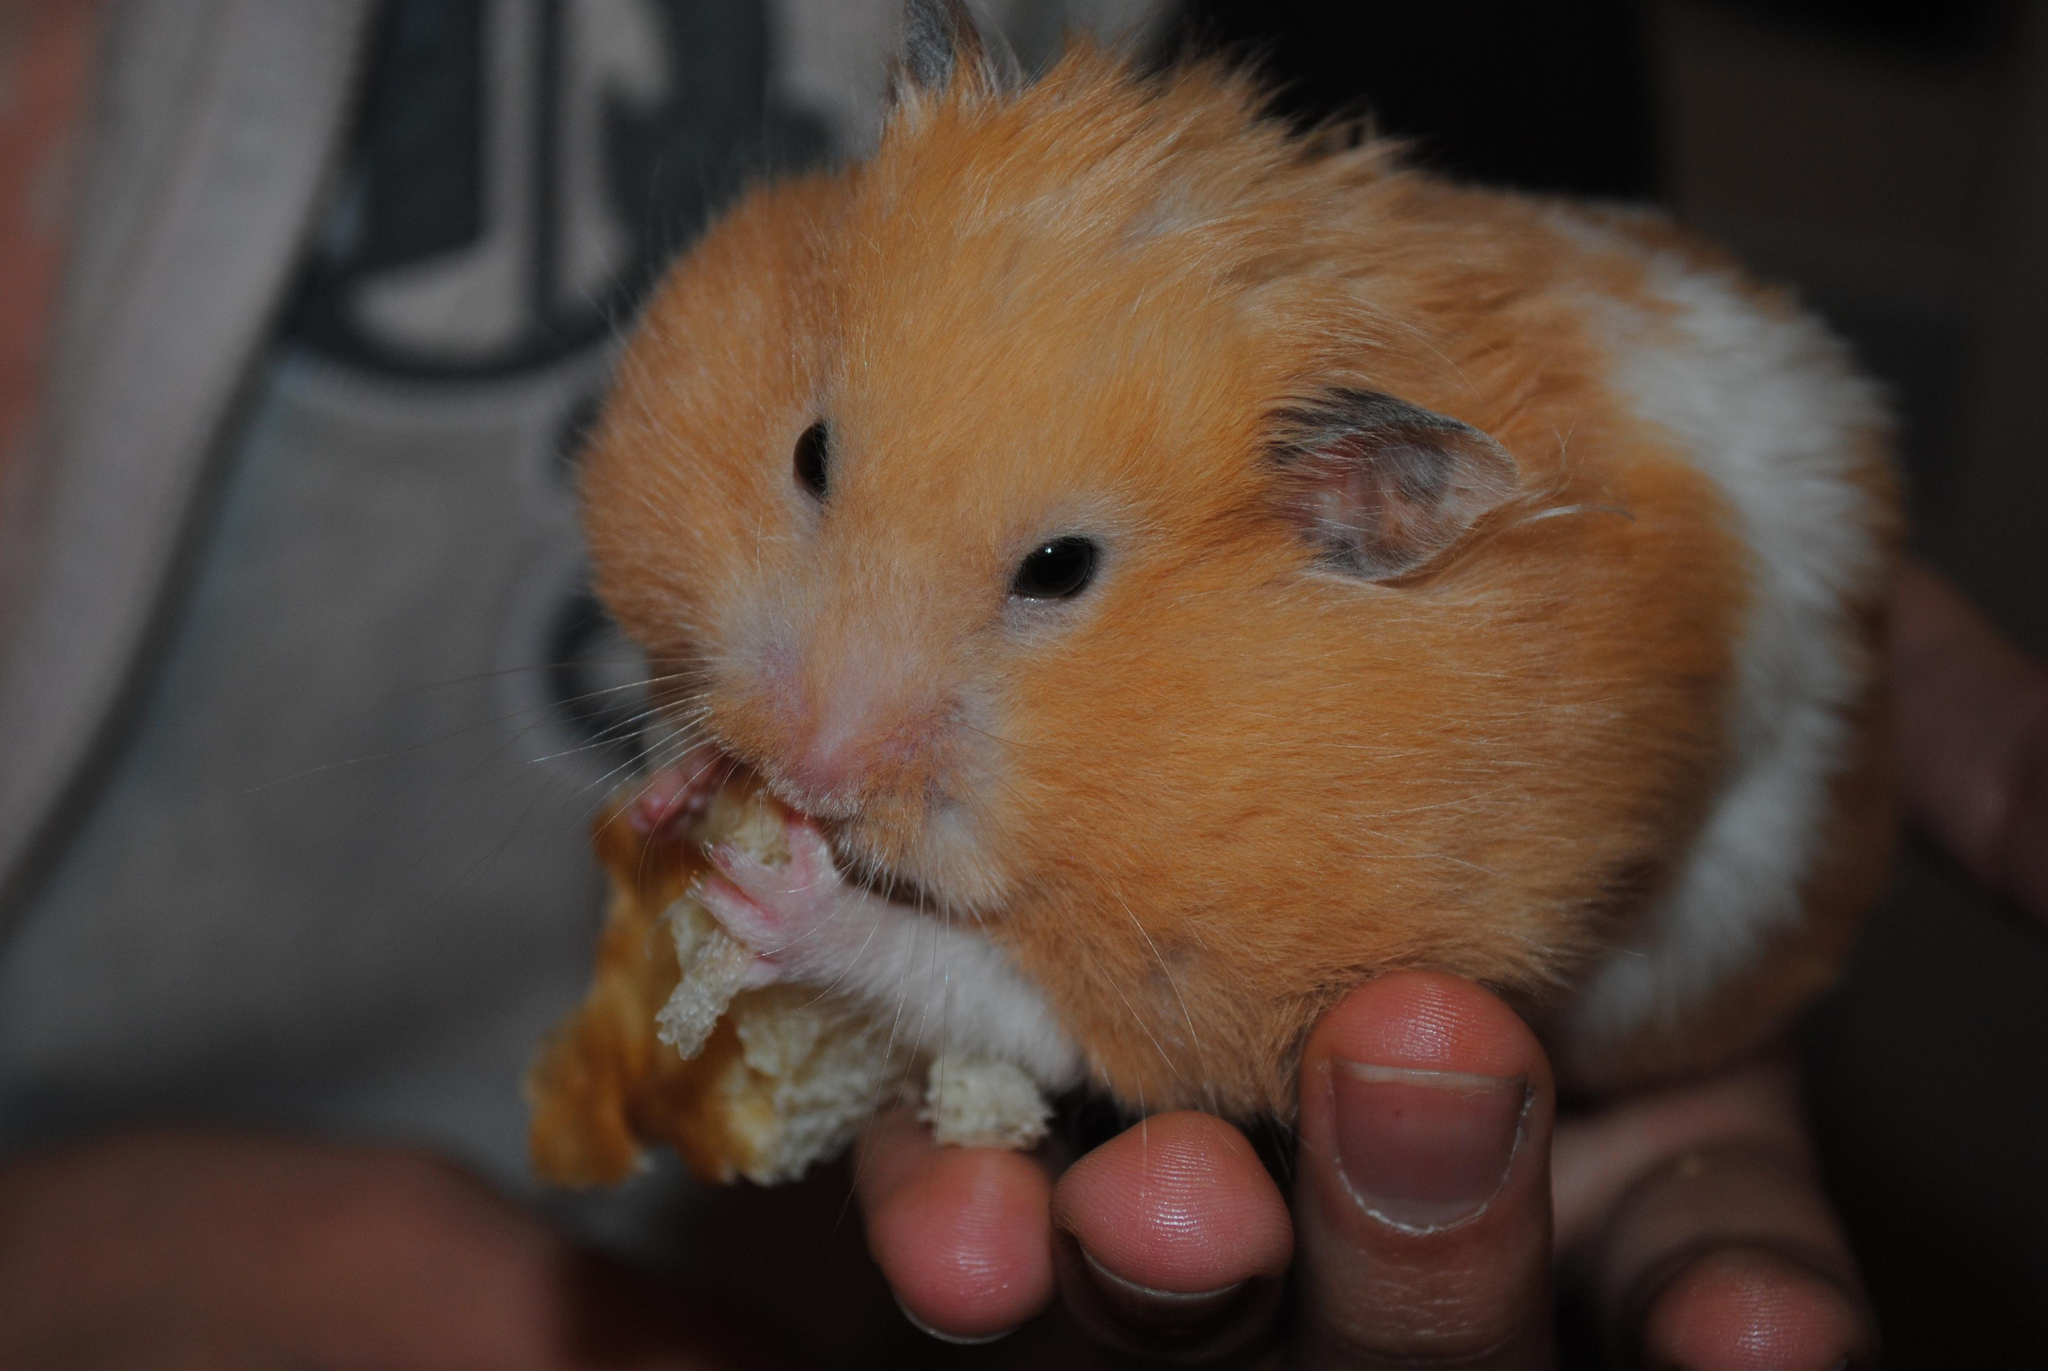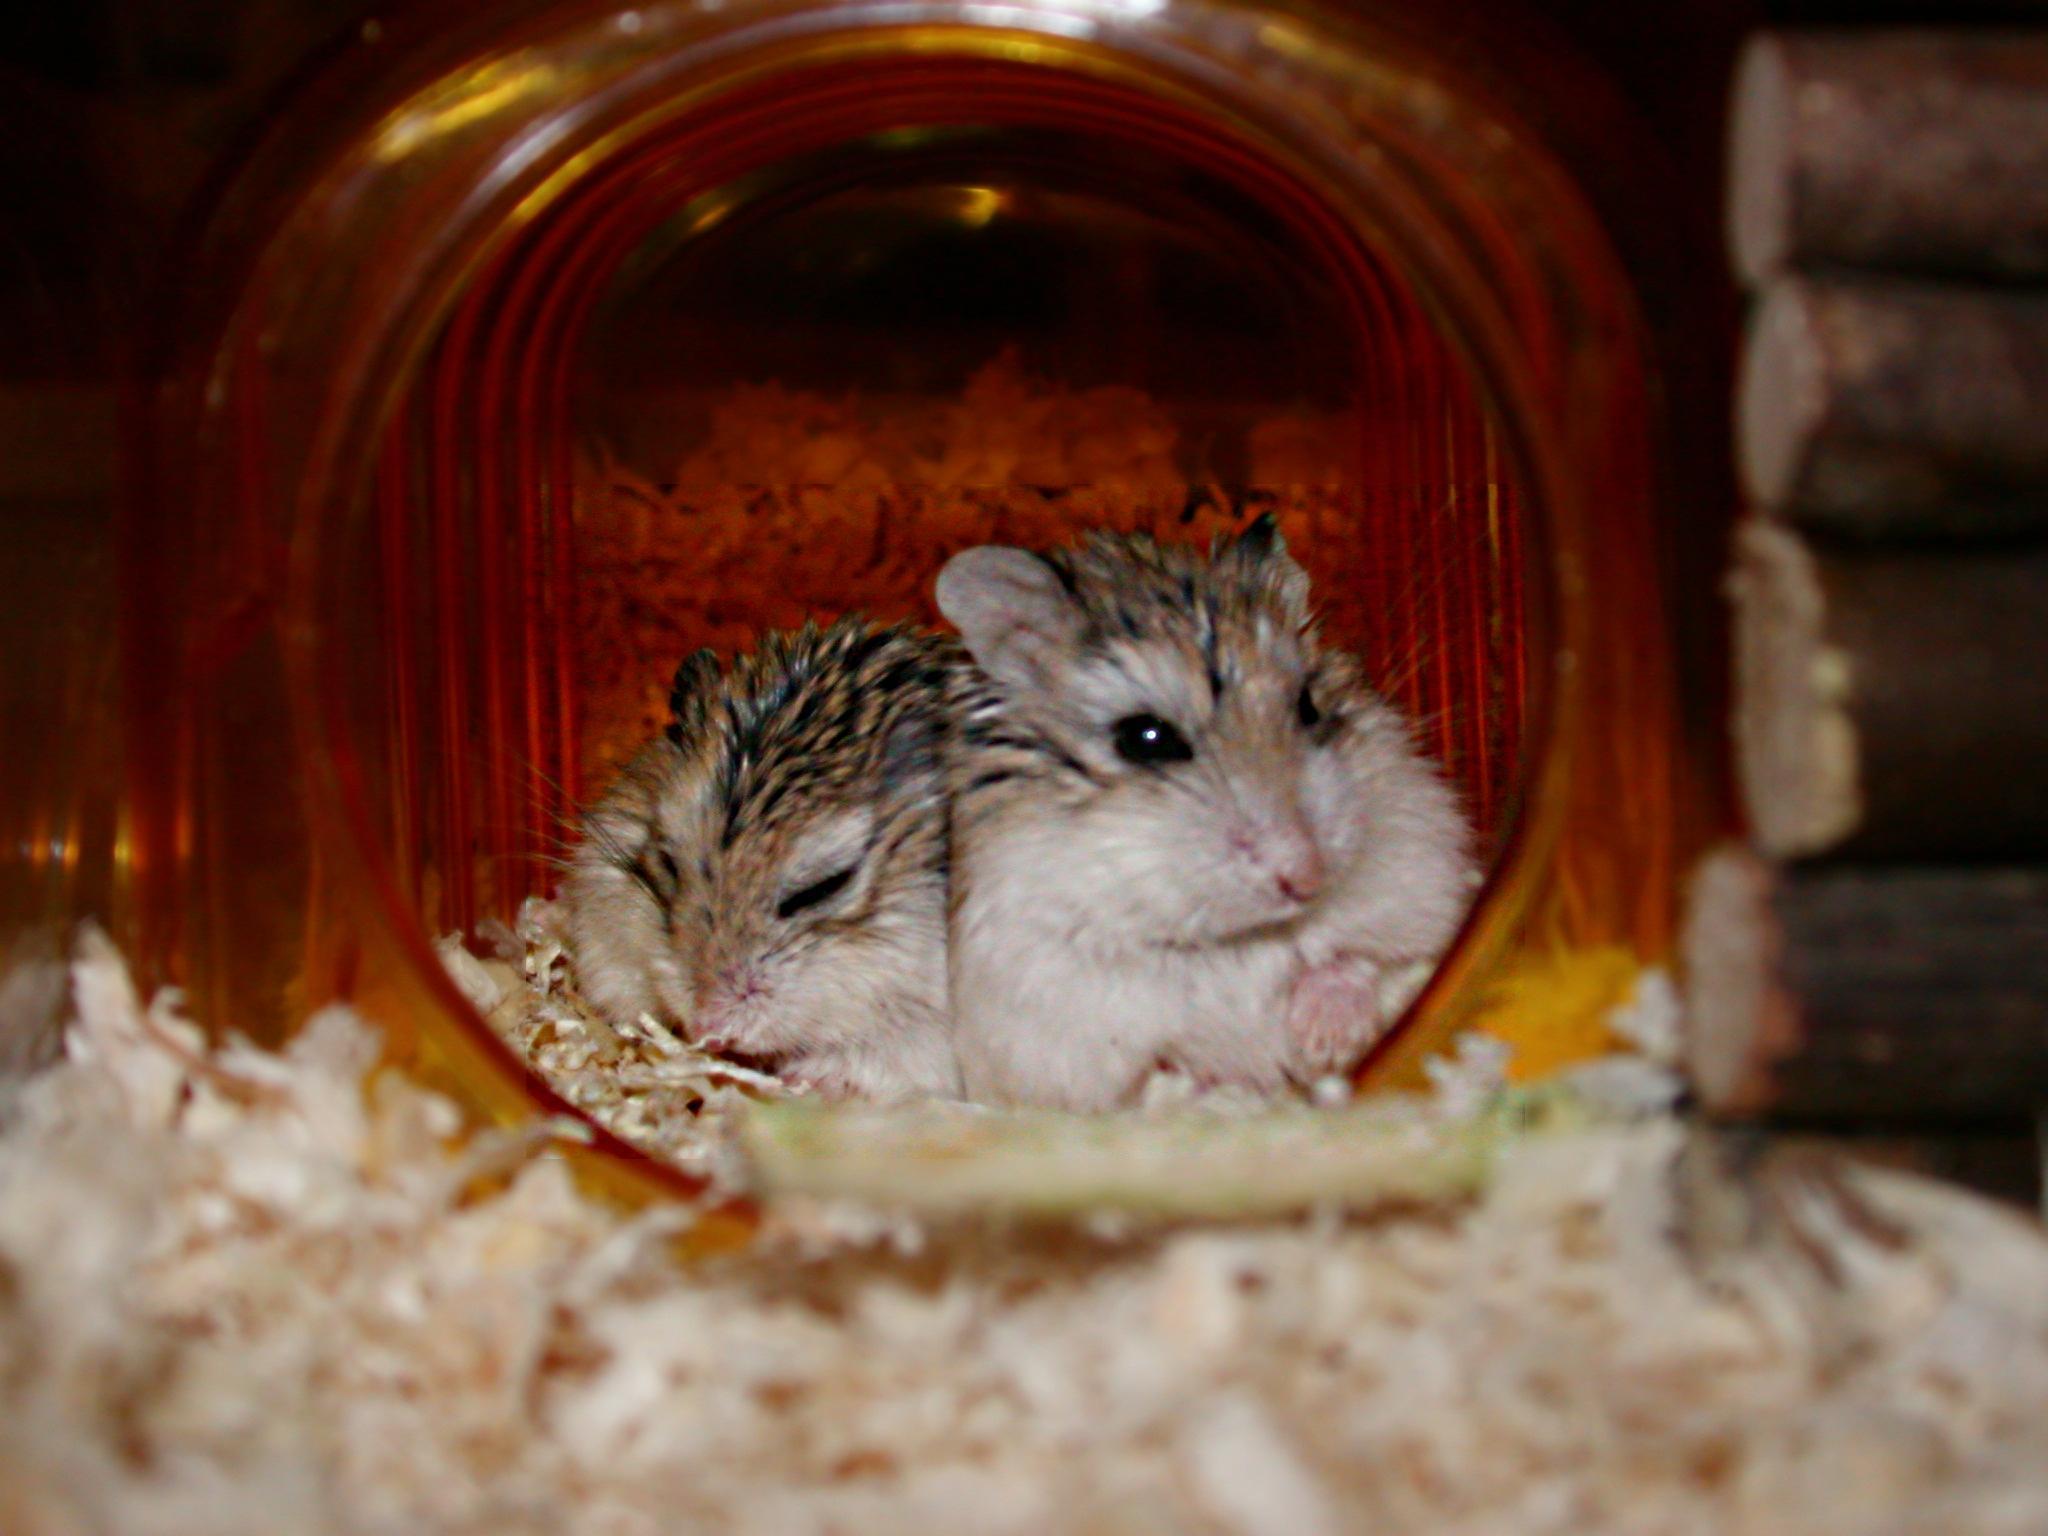The first image is the image on the left, the second image is the image on the right. Evaluate the accuracy of this statement regarding the images: "An image shows pet rodents inside a container with an opening at the front.". Is it true? Answer yes or no. Yes. The first image is the image on the left, the second image is the image on the right. Given the left and right images, does the statement "There is human hand carrying a hamster." hold true? Answer yes or no. Yes. 